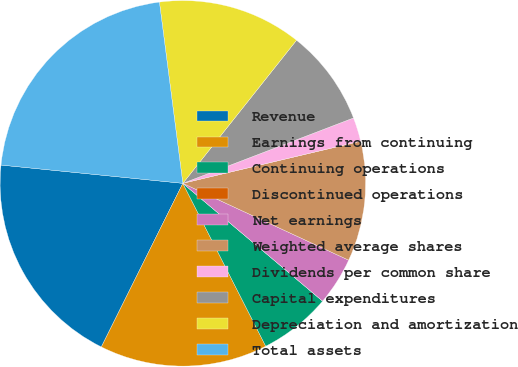Convert chart to OTSL. <chart><loc_0><loc_0><loc_500><loc_500><pie_chart><fcel>Revenue<fcel>Earnings from continuing<fcel>Continuing operations<fcel>Discontinued operations<fcel>Net earnings<fcel>Weighted average shares<fcel>Dividends per common share<fcel>Capital expenditures<fcel>Depreciation and amortization<fcel>Total assets<nl><fcel>19.24%<fcel>14.85%<fcel>6.36%<fcel>0.0%<fcel>4.24%<fcel>10.61%<fcel>2.12%<fcel>8.49%<fcel>12.73%<fcel>21.36%<nl></chart> 